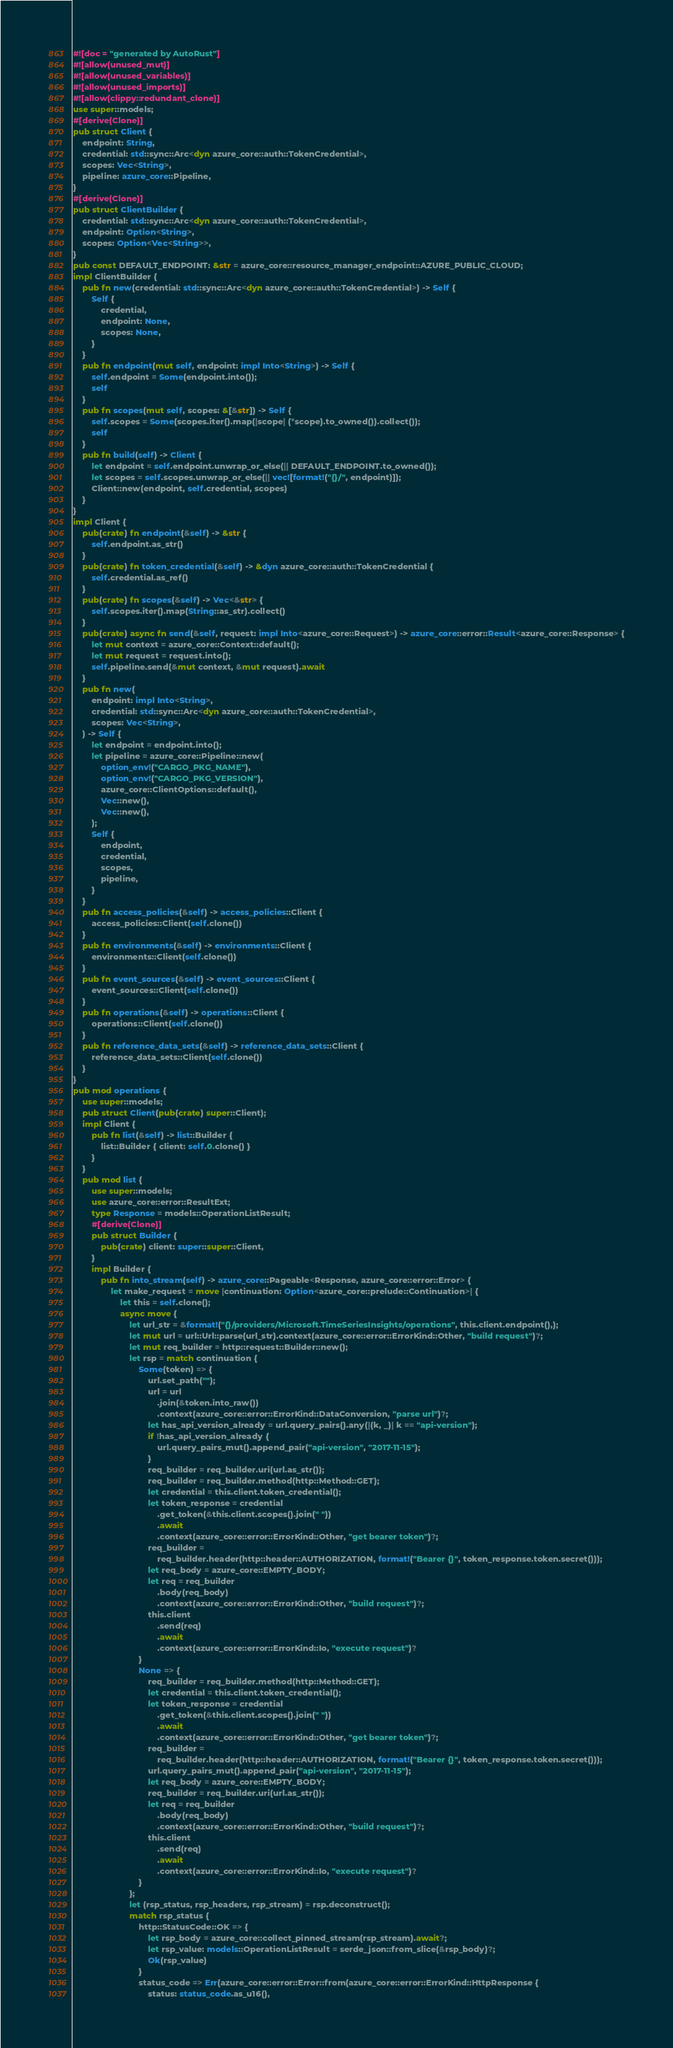Convert code to text. <code><loc_0><loc_0><loc_500><loc_500><_Rust_>#![doc = "generated by AutoRust"]
#![allow(unused_mut)]
#![allow(unused_variables)]
#![allow(unused_imports)]
#![allow(clippy::redundant_clone)]
use super::models;
#[derive(Clone)]
pub struct Client {
    endpoint: String,
    credential: std::sync::Arc<dyn azure_core::auth::TokenCredential>,
    scopes: Vec<String>,
    pipeline: azure_core::Pipeline,
}
#[derive(Clone)]
pub struct ClientBuilder {
    credential: std::sync::Arc<dyn azure_core::auth::TokenCredential>,
    endpoint: Option<String>,
    scopes: Option<Vec<String>>,
}
pub const DEFAULT_ENDPOINT: &str = azure_core::resource_manager_endpoint::AZURE_PUBLIC_CLOUD;
impl ClientBuilder {
    pub fn new(credential: std::sync::Arc<dyn azure_core::auth::TokenCredential>) -> Self {
        Self {
            credential,
            endpoint: None,
            scopes: None,
        }
    }
    pub fn endpoint(mut self, endpoint: impl Into<String>) -> Self {
        self.endpoint = Some(endpoint.into());
        self
    }
    pub fn scopes(mut self, scopes: &[&str]) -> Self {
        self.scopes = Some(scopes.iter().map(|scope| (*scope).to_owned()).collect());
        self
    }
    pub fn build(self) -> Client {
        let endpoint = self.endpoint.unwrap_or_else(|| DEFAULT_ENDPOINT.to_owned());
        let scopes = self.scopes.unwrap_or_else(|| vec![format!("{}/", endpoint)]);
        Client::new(endpoint, self.credential, scopes)
    }
}
impl Client {
    pub(crate) fn endpoint(&self) -> &str {
        self.endpoint.as_str()
    }
    pub(crate) fn token_credential(&self) -> &dyn azure_core::auth::TokenCredential {
        self.credential.as_ref()
    }
    pub(crate) fn scopes(&self) -> Vec<&str> {
        self.scopes.iter().map(String::as_str).collect()
    }
    pub(crate) async fn send(&self, request: impl Into<azure_core::Request>) -> azure_core::error::Result<azure_core::Response> {
        let mut context = azure_core::Context::default();
        let mut request = request.into();
        self.pipeline.send(&mut context, &mut request).await
    }
    pub fn new(
        endpoint: impl Into<String>,
        credential: std::sync::Arc<dyn azure_core::auth::TokenCredential>,
        scopes: Vec<String>,
    ) -> Self {
        let endpoint = endpoint.into();
        let pipeline = azure_core::Pipeline::new(
            option_env!("CARGO_PKG_NAME"),
            option_env!("CARGO_PKG_VERSION"),
            azure_core::ClientOptions::default(),
            Vec::new(),
            Vec::new(),
        );
        Self {
            endpoint,
            credential,
            scopes,
            pipeline,
        }
    }
    pub fn access_policies(&self) -> access_policies::Client {
        access_policies::Client(self.clone())
    }
    pub fn environments(&self) -> environments::Client {
        environments::Client(self.clone())
    }
    pub fn event_sources(&self) -> event_sources::Client {
        event_sources::Client(self.clone())
    }
    pub fn operations(&self) -> operations::Client {
        operations::Client(self.clone())
    }
    pub fn reference_data_sets(&self) -> reference_data_sets::Client {
        reference_data_sets::Client(self.clone())
    }
}
pub mod operations {
    use super::models;
    pub struct Client(pub(crate) super::Client);
    impl Client {
        pub fn list(&self) -> list::Builder {
            list::Builder { client: self.0.clone() }
        }
    }
    pub mod list {
        use super::models;
        use azure_core::error::ResultExt;
        type Response = models::OperationListResult;
        #[derive(Clone)]
        pub struct Builder {
            pub(crate) client: super::super::Client,
        }
        impl Builder {
            pub fn into_stream(self) -> azure_core::Pageable<Response, azure_core::error::Error> {
                let make_request = move |continuation: Option<azure_core::prelude::Continuation>| {
                    let this = self.clone();
                    async move {
                        let url_str = &format!("{}/providers/Microsoft.TimeSeriesInsights/operations", this.client.endpoint(),);
                        let mut url = url::Url::parse(url_str).context(azure_core::error::ErrorKind::Other, "build request")?;
                        let mut req_builder = http::request::Builder::new();
                        let rsp = match continuation {
                            Some(token) => {
                                url.set_path("");
                                url = url
                                    .join(&token.into_raw())
                                    .context(azure_core::error::ErrorKind::DataConversion, "parse url")?;
                                let has_api_version_already = url.query_pairs().any(|(k, _)| k == "api-version");
                                if !has_api_version_already {
                                    url.query_pairs_mut().append_pair("api-version", "2017-11-15");
                                }
                                req_builder = req_builder.uri(url.as_str());
                                req_builder = req_builder.method(http::Method::GET);
                                let credential = this.client.token_credential();
                                let token_response = credential
                                    .get_token(&this.client.scopes().join(" "))
                                    .await
                                    .context(azure_core::error::ErrorKind::Other, "get bearer token")?;
                                req_builder =
                                    req_builder.header(http::header::AUTHORIZATION, format!("Bearer {}", token_response.token.secret()));
                                let req_body = azure_core::EMPTY_BODY;
                                let req = req_builder
                                    .body(req_body)
                                    .context(azure_core::error::ErrorKind::Other, "build request")?;
                                this.client
                                    .send(req)
                                    .await
                                    .context(azure_core::error::ErrorKind::Io, "execute request")?
                            }
                            None => {
                                req_builder = req_builder.method(http::Method::GET);
                                let credential = this.client.token_credential();
                                let token_response = credential
                                    .get_token(&this.client.scopes().join(" "))
                                    .await
                                    .context(azure_core::error::ErrorKind::Other, "get bearer token")?;
                                req_builder =
                                    req_builder.header(http::header::AUTHORIZATION, format!("Bearer {}", token_response.token.secret()));
                                url.query_pairs_mut().append_pair("api-version", "2017-11-15");
                                let req_body = azure_core::EMPTY_BODY;
                                req_builder = req_builder.uri(url.as_str());
                                let req = req_builder
                                    .body(req_body)
                                    .context(azure_core::error::ErrorKind::Other, "build request")?;
                                this.client
                                    .send(req)
                                    .await
                                    .context(azure_core::error::ErrorKind::Io, "execute request")?
                            }
                        };
                        let (rsp_status, rsp_headers, rsp_stream) = rsp.deconstruct();
                        match rsp_status {
                            http::StatusCode::OK => {
                                let rsp_body = azure_core::collect_pinned_stream(rsp_stream).await?;
                                let rsp_value: models::OperationListResult = serde_json::from_slice(&rsp_body)?;
                                Ok(rsp_value)
                            }
                            status_code => Err(azure_core::error::Error::from(azure_core::error::ErrorKind::HttpResponse {
                                status: status_code.as_u16(),</code> 